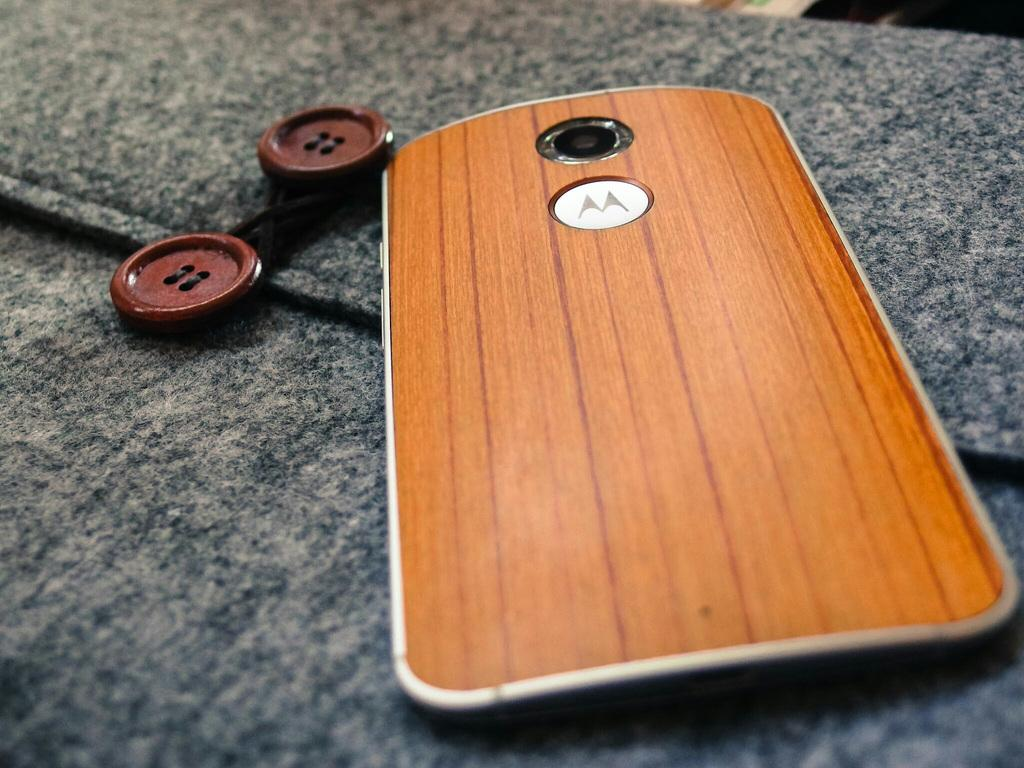<image>
Share a concise interpretation of the image provided. A cell phone with a simulated wood finish has the Motorola logo on its back. 